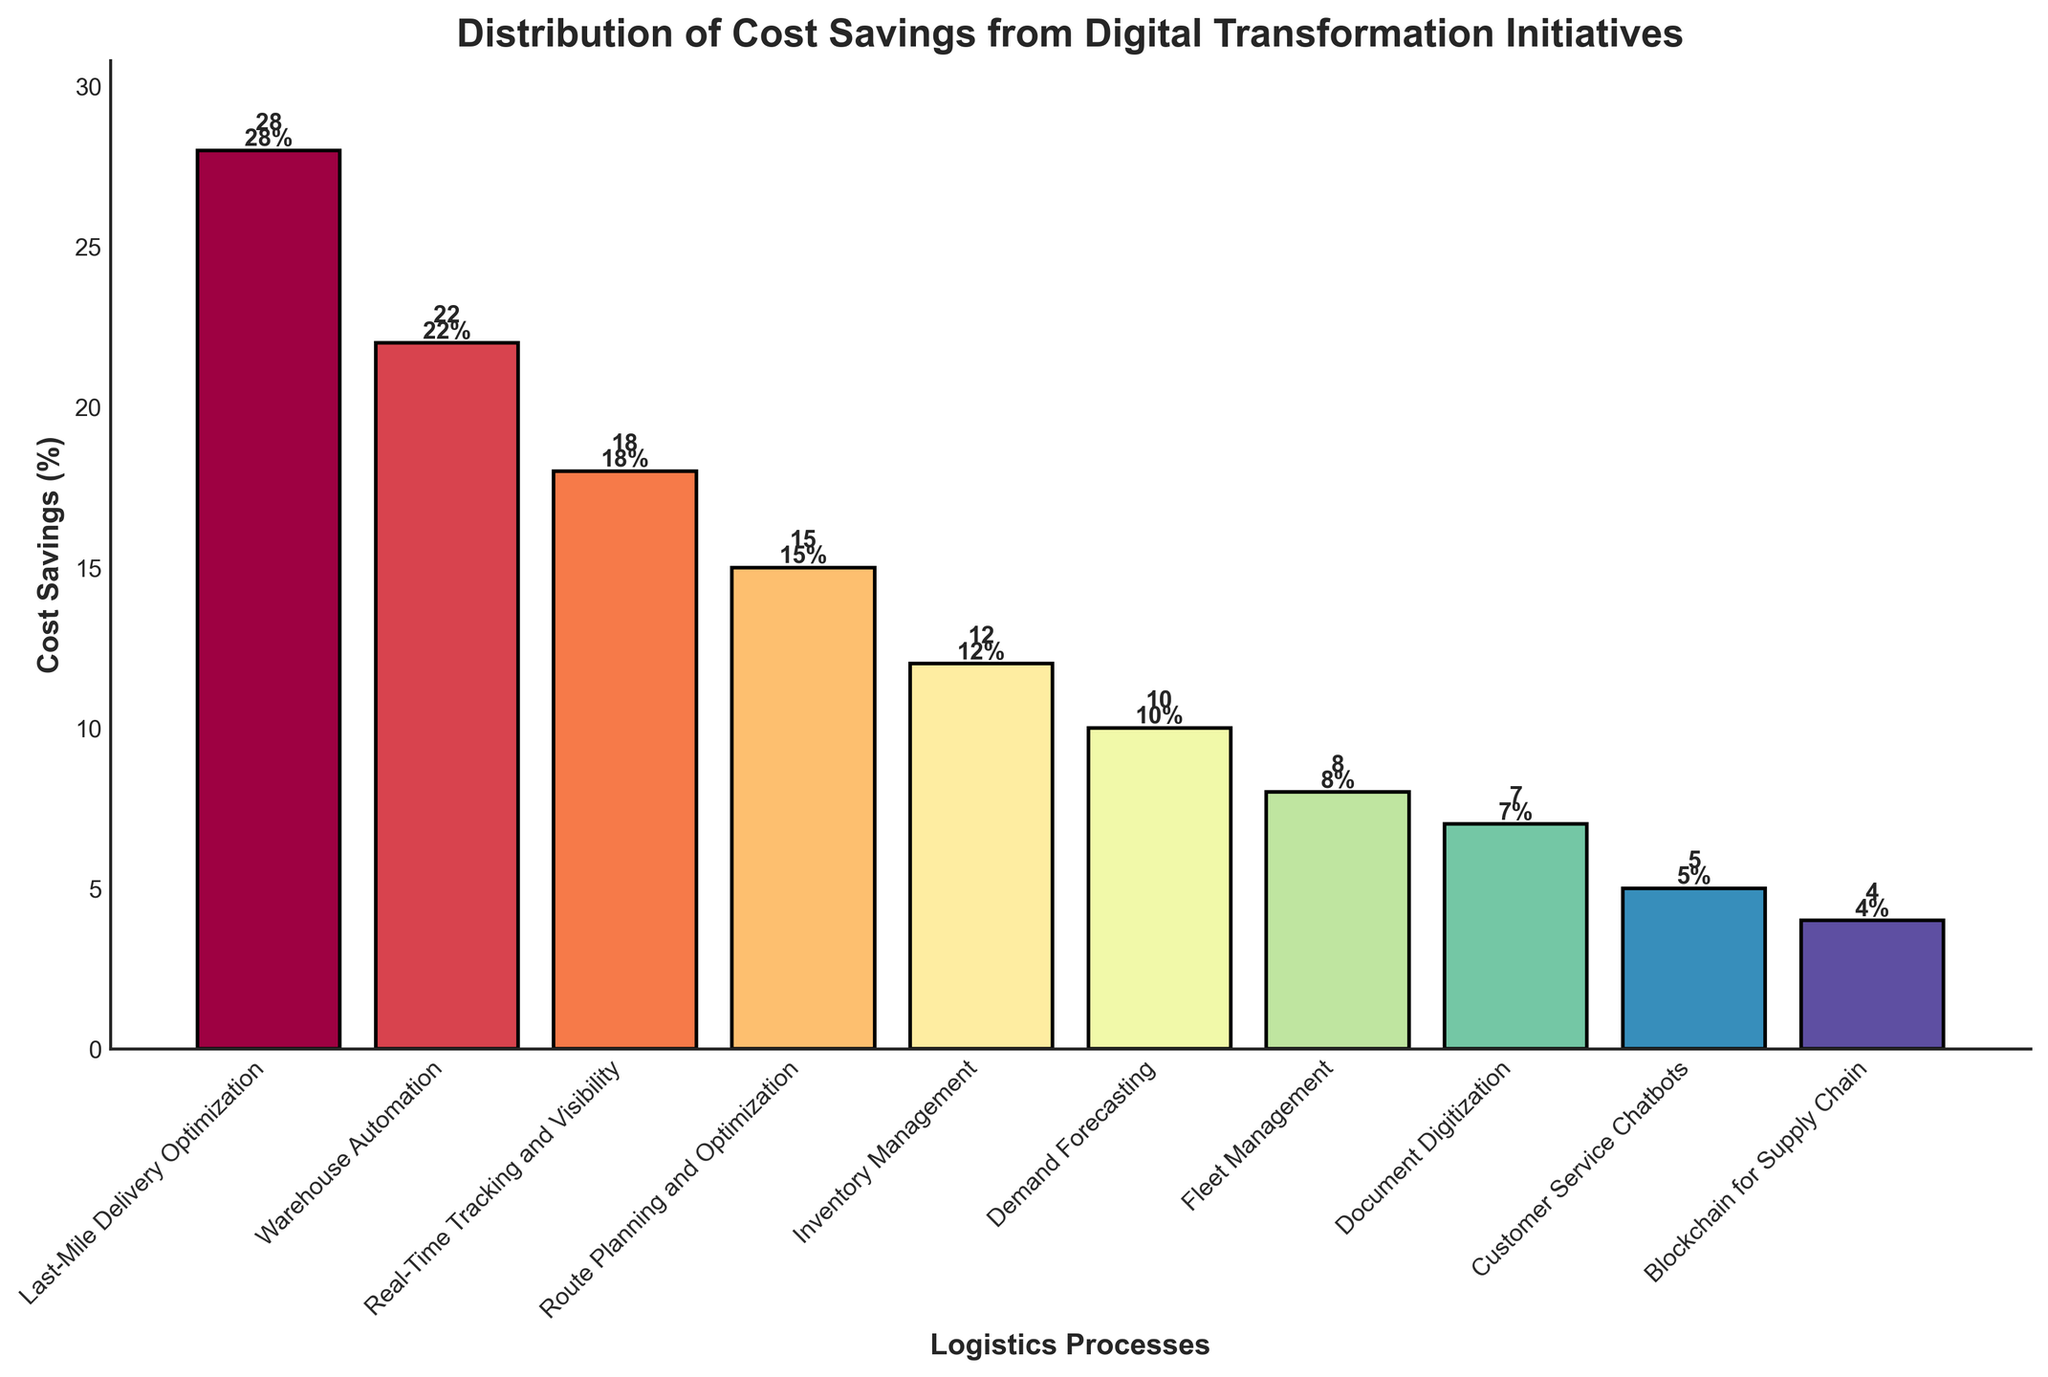Which logistics process shows the highest cost savings from digital transformation initiatives? The bar for 'Last-Mile Delivery Optimization' reaches the highest value among all the processes in the figure, indicating the highest cost savings.
Answer: Last-Mile Delivery Optimization Which two logistics processes have the closest cost savings percentages? 'Customer Service Chatbots' at 5% and 'Blockchain for Supply Chain' at 4% are the closest in cost savings percentages, based on the lengths of their respective bars and the numerical labels.
Answer: Customer Service Chatbots and Blockchain for Supply Chain What is the total cost savings percentage for the top three logistics processes? The top three logistics processes by cost savings are 'Last-Mile Delivery Optimization' (28%), 'Warehouse Automation' (22%), and 'Real-Time Tracking and Visibility' (18%). Summing these values gives 28 + 22 + 18 = 68.
Answer: 68% How much more cost savings does 'Real-Time Tracking and Visibility' provide compared to 'Inventory Management'? 'Real-Time Tracking and Visibility' offers 18% cost savings, while 'Inventory Management' provides 12%. The difference is 18 - 12 = 6.
Answer: 6% Which logistics process has the smallest cost savings percentage, and what is that percentage? The shortest bar in the figure, labeled with the smallest value, corresponds to 'Blockchain for Supply Chain' with a cost savings of 4%.
Answer: Blockchain for Supply Chain, 4% How does the cost savings percentage of 'Fleet Management' compare to 'Demand Forecasting'? The bar representing 'Demand Forecasting' shows a 10% cost savings, compared to 'Fleet Management', which has an 8% cost savings. Thus, 'Demand Forecasting' is 2% higher.
Answer: Demand Forecasting is 2% higher Calculate the average cost savings for the bottom five logistics processes. The bottom five processes by cost savings are 'Customer Service Chatbots' (5%), 'Blockchain for Supply Chain' (4%), 'Document Digitization' (7%), 'Fleet Management' (8%), and 'Demand Forecasting' (10%). Summing these values gives 5 + 4 + 7 + 8 + 10 = 34. The average is 34 / 5 = 6.8.
Answer: 6.8% What is the range of cost savings percentages for all logistics processes? The highest cost savings percentage is from 'Last-Mile Delivery Optimization' (28%) and the lowest is from 'Blockchain for Supply Chain' (4%). The range is 28 - 4 = 24.
Answer: 24% Which logistics process has a cost savings percentage that is closest to the average cost savings of all processes? Summing all cost savings percentages: 28 + 22 + 18 + 15 + 12 + 10 + 8 + 7 + 5 + 4 = 129. The average is 129 / 10 = 12.9. 'Inventory Management' with a 12% cost savings is closest to this average.
Answer: Inventory Management List the logistics processes that have more than 15% cost savings. The bars representing 'Last-Mile Delivery Optimization' (28%), 'Warehouse Automation' (22%), and 'Real-Time Tracking and Visibility' (18%) all show cost savings higher than 15%.
Answer: Last-Mile Delivery Optimization, Warehouse Automation, Real-Time Tracking and Visibility 